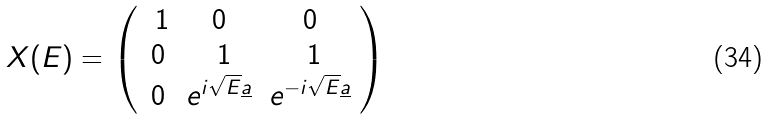Convert formula to latex. <formula><loc_0><loc_0><loc_500><loc_500>X ( E ) = \left ( \begin{array} { c c c } \ 1 & 0 & 0 \\ 0 & \ 1 & \ 1 \\ 0 & e ^ { i \sqrt { E } \underline { a } } & e ^ { - i \sqrt { E } \underline { a } } \end{array} \right )</formula> 